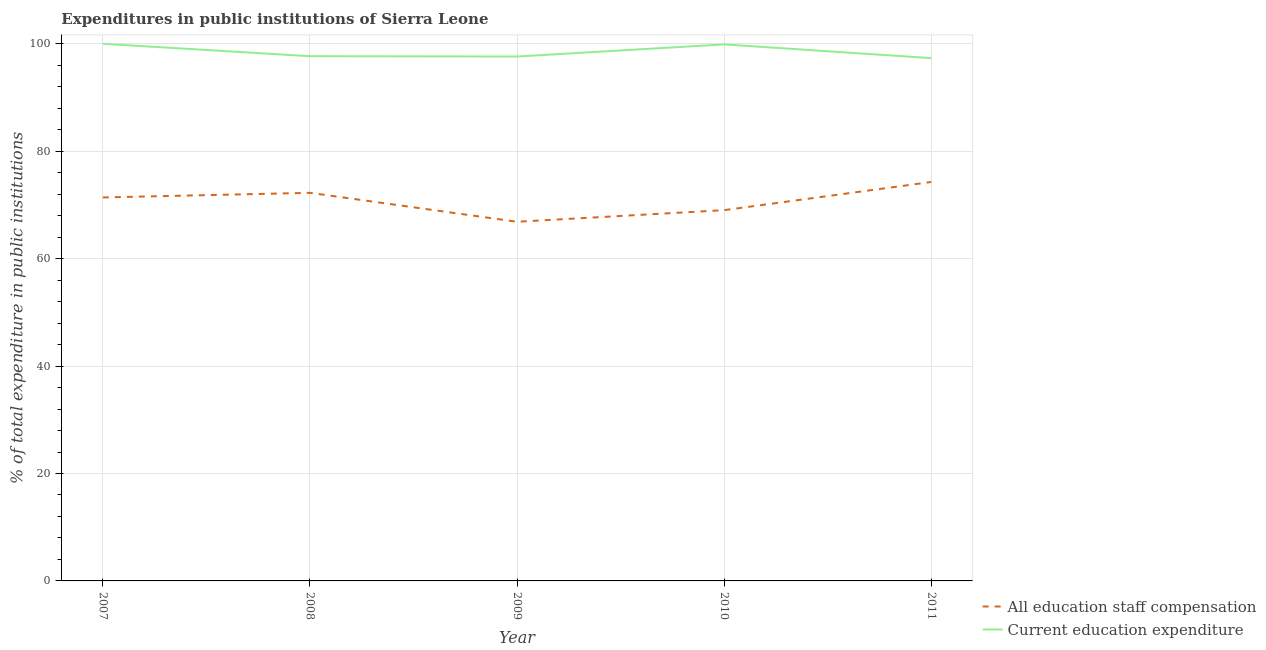How many different coloured lines are there?
Your response must be concise. 2. Does the line corresponding to expenditure in education intersect with the line corresponding to expenditure in staff compensation?
Offer a very short reply. No. Is the number of lines equal to the number of legend labels?
Offer a very short reply. Yes. What is the expenditure in education in 2008?
Your answer should be very brief. 97.69. Across all years, what is the maximum expenditure in staff compensation?
Your answer should be compact. 74.27. Across all years, what is the minimum expenditure in staff compensation?
Offer a very short reply. 66.86. In which year was the expenditure in education minimum?
Ensure brevity in your answer.  2011. What is the total expenditure in staff compensation in the graph?
Your answer should be compact. 353.8. What is the difference between the expenditure in staff compensation in 2008 and that in 2011?
Your answer should be very brief. -2.02. What is the difference between the expenditure in education in 2011 and the expenditure in staff compensation in 2009?
Your response must be concise. 30.46. What is the average expenditure in staff compensation per year?
Your answer should be very brief. 70.76. In the year 2007, what is the difference between the expenditure in education and expenditure in staff compensation?
Your response must be concise. 28.61. What is the ratio of the expenditure in education in 2009 to that in 2010?
Give a very brief answer. 0.98. What is the difference between the highest and the second highest expenditure in education?
Keep it short and to the point. 0.11. What is the difference between the highest and the lowest expenditure in staff compensation?
Ensure brevity in your answer.  7.41. In how many years, is the expenditure in education greater than the average expenditure in education taken over all years?
Your response must be concise. 2. Does the graph contain any zero values?
Give a very brief answer. No. How many legend labels are there?
Your response must be concise. 2. How are the legend labels stacked?
Your answer should be very brief. Vertical. What is the title of the graph?
Give a very brief answer. Expenditures in public institutions of Sierra Leone. What is the label or title of the Y-axis?
Make the answer very short. % of total expenditure in public institutions. What is the % of total expenditure in public institutions in All education staff compensation in 2007?
Your response must be concise. 71.39. What is the % of total expenditure in public institutions of Current education expenditure in 2007?
Provide a succinct answer. 100. What is the % of total expenditure in public institutions of All education staff compensation in 2008?
Your answer should be compact. 72.25. What is the % of total expenditure in public institutions in Current education expenditure in 2008?
Give a very brief answer. 97.69. What is the % of total expenditure in public institutions in All education staff compensation in 2009?
Your response must be concise. 66.86. What is the % of total expenditure in public institutions of Current education expenditure in 2009?
Offer a terse response. 97.62. What is the % of total expenditure in public institutions of All education staff compensation in 2010?
Ensure brevity in your answer.  69.03. What is the % of total expenditure in public institutions of Current education expenditure in 2010?
Your answer should be very brief. 99.89. What is the % of total expenditure in public institutions of All education staff compensation in 2011?
Your response must be concise. 74.27. What is the % of total expenditure in public institutions of Current education expenditure in 2011?
Keep it short and to the point. 97.33. Across all years, what is the maximum % of total expenditure in public institutions of All education staff compensation?
Ensure brevity in your answer.  74.27. Across all years, what is the minimum % of total expenditure in public institutions of All education staff compensation?
Keep it short and to the point. 66.86. Across all years, what is the minimum % of total expenditure in public institutions in Current education expenditure?
Give a very brief answer. 97.33. What is the total % of total expenditure in public institutions of All education staff compensation in the graph?
Your answer should be compact. 353.8. What is the total % of total expenditure in public institutions of Current education expenditure in the graph?
Offer a terse response. 492.53. What is the difference between the % of total expenditure in public institutions in All education staff compensation in 2007 and that in 2008?
Your answer should be compact. -0.86. What is the difference between the % of total expenditure in public institutions of Current education expenditure in 2007 and that in 2008?
Ensure brevity in your answer.  2.31. What is the difference between the % of total expenditure in public institutions of All education staff compensation in 2007 and that in 2009?
Give a very brief answer. 4.53. What is the difference between the % of total expenditure in public institutions of Current education expenditure in 2007 and that in 2009?
Ensure brevity in your answer.  2.38. What is the difference between the % of total expenditure in public institutions in All education staff compensation in 2007 and that in 2010?
Provide a succinct answer. 2.36. What is the difference between the % of total expenditure in public institutions in Current education expenditure in 2007 and that in 2010?
Provide a succinct answer. 0.11. What is the difference between the % of total expenditure in public institutions of All education staff compensation in 2007 and that in 2011?
Keep it short and to the point. -2.88. What is the difference between the % of total expenditure in public institutions of Current education expenditure in 2007 and that in 2011?
Your answer should be very brief. 2.67. What is the difference between the % of total expenditure in public institutions of All education staff compensation in 2008 and that in 2009?
Make the answer very short. 5.39. What is the difference between the % of total expenditure in public institutions of Current education expenditure in 2008 and that in 2009?
Keep it short and to the point. 0.06. What is the difference between the % of total expenditure in public institutions of All education staff compensation in 2008 and that in 2010?
Provide a short and direct response. 3.23. What is the difference between the % of total expenditure in public institutions in Current education expenditure in 2008 and that in 2010?
Make the answer very short. -2.2. What is the difference between the % of total expenditure in public institutions of All education staff compensation in 2008 and that in 2011?
Ensure brevity in your answer.  -2.02. What is the difference between the % of total expenditure in public institutions in Current education expenditure in 2008 and that in 2011?
Your response must be concise. 0.36. What is the difference between the % of total expenditure in public institutions in All education staff compensation in 2009 and that in 2010?
Make the answer very short. -2.16. What is the difference between the % of total expenditure in public institutions in Current education expenditure in 2009 and that in 2010?
Offer a terse response. -2.26. What is the difference between the % of total expenditure in public institutions of All education staff compensation in 2009 and that in 2011?
Keep it short and to the point. -7.41. What is the difference between the % of total expenditure in public institutions in Current education expenditure in 2009 and that in 2011?
Offer a very short reply. 0.3. What is the difference between the % of total expenditure in public institutions in All education staff compensation in 2010 and that in 2011?
Provide a succinct answer. -5.24. What is the difference between the % of total expenditure in public institutions of Current education expenditure in 2010 and that in 2011?
Provide a succinct answer. 2.56. What is the difference between the % of total expenditure in public institutions in All education staff compensation in 2007 and the % of total expenditure in public institutions in Current education expenditure in 2008?
Provide a short and direct response. -26.3. What is the difference between the % of total expenditure in public institutions in All education staff compensation in 2007 and the % of total expenditure in public institutions in Current education expenditure in 2009?
Ensure brevity in your answer.  -26.23. What is the difference between the % of total expenditure in public institutions of All education staff compensation in 2007 and the % of total expenditure in public institutions of Current education expenditure in 2010?
Offer a very short reply. -28.5. What is the difference between the % of total expenditure in public institutions of All education staff compensation in 2007 and the % of total expenditure in public institutions of Current education expenditure in 2011?
Keep it short and to the point. -25.94. What is the difference between the % of total expenditure in public institutions of All education staff compensation in 2008 and the % of total expenditure in public institutions of Current education expenditure in 2009?
Provide a short and direct response. -25.37. What is the difference between the % of total expenditure in public institutions of All education staff compensation in 2008 and the % of total expenditure in public institutions of Current education expenditure in 2010?
Offer a very short reply. -27.64. What is the difference between the % of total expenditure in public institutions of All education staff compensation in 2008 and the % of total expenditure in public institutions of Current education expenditure in 2011?
Provide a short and direct response. -25.07. What is the difference between the % of total expenditure in public institutions of All education staff compensation in 2009 and the % of total expenditure in public institutions of Current education expenditure in 2010?
Your answer should be compact. -33.02. What is the difference between the % of total expenditure in public institutions in All education staff compensation in 2009 and the % of total expenditure in public institutions in Current education expenditure in 2011?
Provide a short and direct response. -30.46. What is the difference between the % of total expenditure in public institutions in All education staff compensation in 2010 and the % of total expenditure in public institutions in Current education expenditure in 2011?
Offer a very short reply. -28.3. What is the average % of total expenditure in public institutions in All education staff compensation per year?
Your answer should be very brief. 70.76. What is the average % of total expenditure in public institutions of Current education expenditure per year?
Make the answer very short. 98.51. In the year 2007, what is the difference between the % of total expenditure in public institutions in All education staff compensation and % of total expenditure in public institutions in Current education expenditure?
Offer a terse response. -28.61. In the year 2008, what is the difference between the % of total expenditure in public institutions of All education staff compensation and % of total expenditure in public institutions of Current education expenditure?
Make the answer very short. -25.43. In the year 2009, what is the difference between the % of total expenditure in public institutions in All education staff compensation and % of total expenditure in public institutions in Current education expenditure?
Provide a succinct answer. -30.76. In the year 2010, what is the difference between the % of total expenditure in public institutions of All education staff compensation and % of total expenditure in public institutions of Current education expenditure?
Provide a short and direct response. -30.86. In the year 2011, what is the difference between the % of total expenditure in public institutions of All education staff compensation and % of total expenditure in public institutions of Current education expenditure?
Your answer should be compact. -23.06. What is the ratio of the % of total expenditure in public institutions of All education staff compensation in 2007 to that in 2008?
Give a very brief answer. 0.99. What is the ratio of the % of total expenditure in public institutions in Current education expenditure in 2007 to that in 2008?
Your answer should be compact. 1.02. What is the ratio of the % of total expenditure in public institutions of All education staff compensation in 2007 to that in 2009?
Offer a very short reply. 1.07. What is the ratio of the % of total expenditure in public institutions in Current education expenditure in 2007 to that in 2009?
Provide a short and direct response. 1.02. What is the ratio of the % of total expenditure in public institutions of All education staff compensation in 2007 to that in 2010?
Offer a terse response. 1.03. What is the ratio of the % of total expenditure in public institutions in All education staff compensation in 2007 to that in 2011?
Your answer should be compact. 0.96. What is the ratio of the % of total expenditure in public institutions in Current education expenditure in 2007 to that in 2011?
Your response must be concise. 1.03. What is the ratio of the % of total expenditure in public institutions of All education staff compensation in 2008 to that in 2009?
Give a very brief answer. 1.08. What is the ratio of the % of total expenditure in public institutions in All education staff compensation in 2008 to that in 2010?
Your response must be concise. 1.05. What is the ratio of the % of total expenditure in public institutions in All education staff compensation in 2008 to that in 2011?
Provide a succinct answer. 0.97. What is the ratio of the % of total expenditure in public institutions in All education staff compensation in 2009 to that in 2010?
Offer a terse response. 0.97. What is the ratio of the % of total expenditure in public institutions in Current education expenditure in 2009 to that in 2010?
Make the answer very short. 0.98. What is the ratio of the % of total expenditure in public institutions in All education staff compensation in 2009 to that in 2011?
Offer a very short reply. 0.9. What is the ratio of the % of total expenditure in public institutions of Current education expenditure in 2009 to that in 2011?
Your answer should be compact. 1. What is the ratio of the % of total expenditure in public institutions of All education staff compensation in 2010 to that in 2011?
Your response must be concise. 0.93. What is the ratio of the % of total expenditure in public institutions of Current education expenditure in 2010 to that in 2011?
Your response must be concise. 1.03. What is the difference between the highest and the second highest % of total expenditure in public institutions in All education staff compensation?
Offer a very short reply. 2.02. What is the difference between the highest and the second highest % of total expenditure in public institutions in Current education expenditure?
Your response must be concise. 0.11. What is the difference between the highest and the lowest % of total expenditure in public institutions of All education staff compensation?
Your answer should be compact. 7.41. What is the difference between the highest and the lowest % of total expenditure in public institutions of Current education expenditure?
Give a very brief answer. 2.67. 